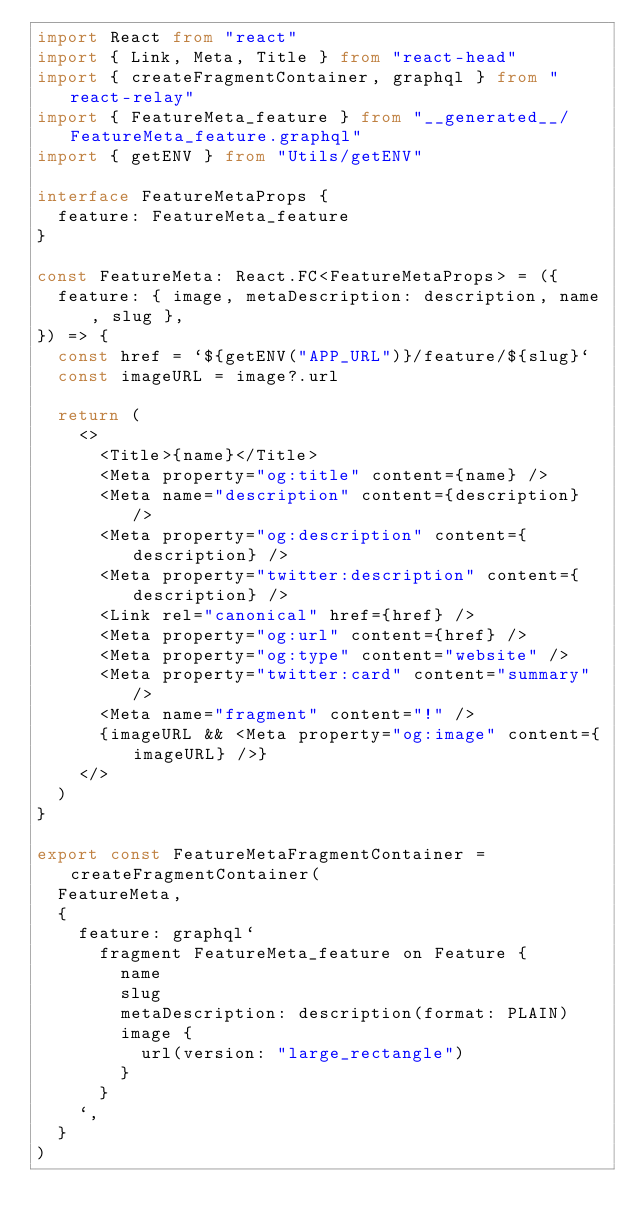Convert code to text. <code><loc_0><loc_0><loc_500><loc_500><_TypeScript_>import React from "react"
import { Link, Meta, Title } from "react-head"
import { createFragmentContainer, graphql } from "react-relay"
import { FeatureMeta_feature } from "__generated__/FeatureMeta_feature.graphql"
import { getENV } from "Utils/getENV"

interface FeatureMetaProps {
  feature: FeatureMeta_feature
}

const FeatureMeta: React.FC<FeatureMetaProps> = ({
  feature: { image, metaDescription: description, name, slug },
}) => {
  const href = `${getENV("APP_URL")}/feature/${slug}`
  const imageURL = image?.url

  return (
    <>
      <Title>{name}</Title>
      <Meta property="og:title" content={name} />
      <Meta name="description" content={description} />
      <Meta property="og:description" content={description} />
      <Meta property="twitter:description" content={description} />
      <Link rel="canonical" href={href} />
      <Meta property="og:url" content={href} />
      <Meta property="og:type" content="website" />
      <Meta property="twitter:card" content="summary" />
      <Meta name="fragment" content="!" />
      {imageURL && <Meta property="og:image" content={imageURL} />}
    </>
  )
}

export const FeatureMetaFragmentContainer = createFragmentContainer(
  FeatureMeta,
  {
    feature: graphql`
      fragment FeatureMeta_feature on Feature {
        name
        slug
        metaDescription: description(format: PLAIN)
        image {
          url(version: "large_rectangle")
        }
      }
    `,
  }
)
</code> 